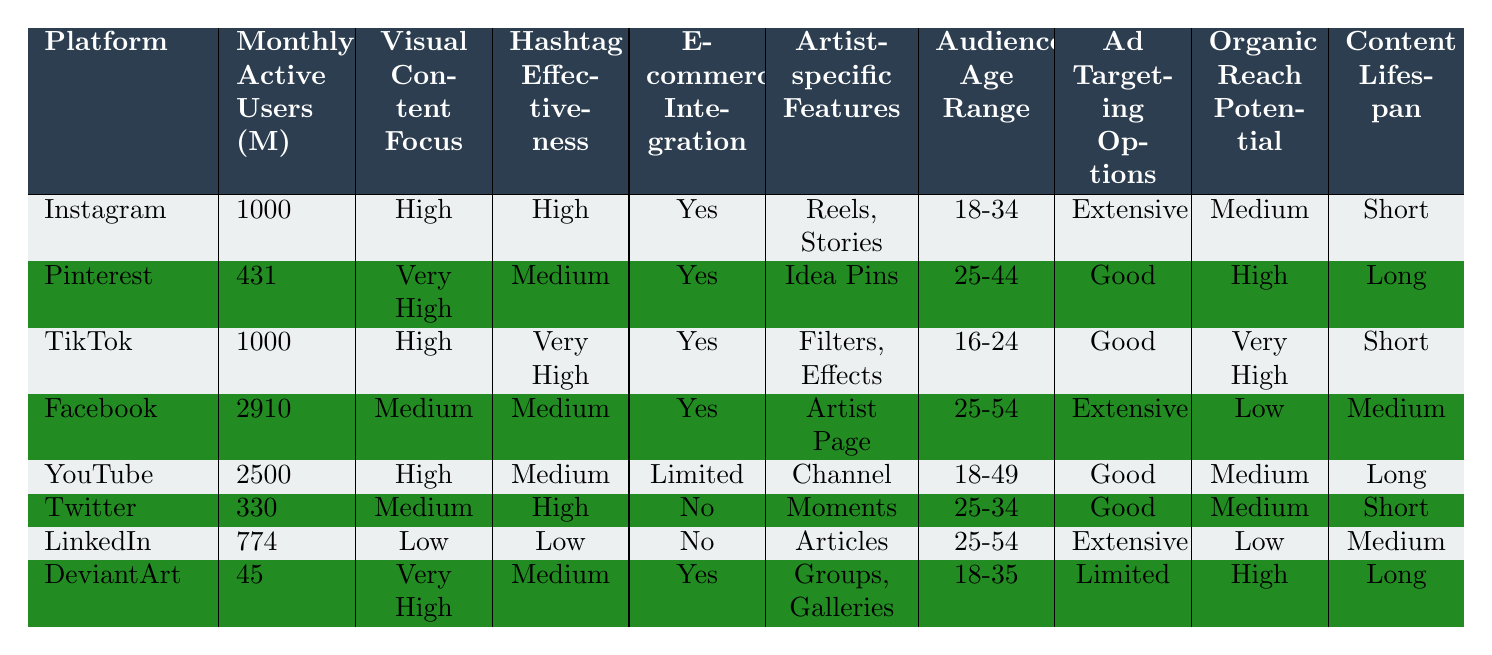What is the platform with the highest number of Monthly Active Users? Facebook has the highest number of Monthly Active Users at 2910 million, as shown in the table.
Answer: Facebook Which platform has the highest Visual Content Focus? Pinterest has the highest Visual Content Focus with a rating of "Very High."
Answer: Pinterest Is there E-commerce Integration available on TikTok? Yes, TikTok provides E-commerce Integration, as indicated in the table.
Answer: Yes What is the Content Lifespan for Instagram? Instagram has a Content Lifespan that is classified as "Short" according to the table.
Answer: Short What is the average number of Monthly Active Users for the platforms focused on visual content? The average Monthly Active Users for Instagram, TikTok, and DeviantArt can be calculated as (1000 + 1000 + 45) / 3 = 348.33 million approximately.
Answer: 348.33 million Which platforms have a medium level of Organic Reach Potential? The platforms with medium Organic Reach Potential are Instagram, YouTube, Twitter, and Facebook.
Answer: Instagram, YouTube, Twitter, Facebook Which platform caters to the youngest audience age range and what is that range? TikTok caters to the youngest audience age range of 16-24, as per the table's data.
Answer: 16-24 Which platforms provide extensive Ad Targeting Options, and how many are there? Instagram, Facebook, and LinkedIn provide extensive Ad Targeting Options; there are three of them.
Answer: 3 What is the relationship between E-commerce Integration and Artist-specific Features for YouTube? YouTube has Limited E-commerce Integration and offers Channel as an Artist-specific Feature, indicating it does not support extensive shopping features for artists.
Answer: Limited E-commerce Integration, Channel feature Do more platforms have High or Medium Hashtag Effectiveness? There are three platforms with High Hashtag Effectiveness (Instagram, TikTok, Twitter) and three with Medium (Pinterest, Facebook, YouTube). Thus, there is an equal count.
Answer: Equal count 